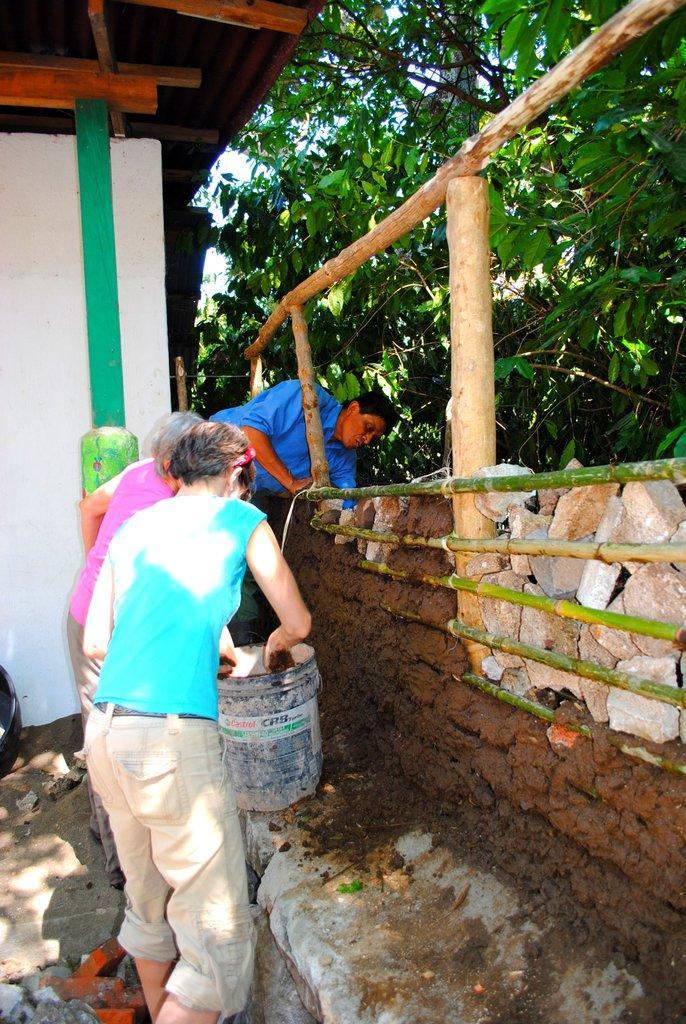Can you describe this image briefly? In this image we can see people building a wall. The person standing in the center is holding a bucket. On the right there are bamboo sticks. In the background there is a shed, trees and sky. 